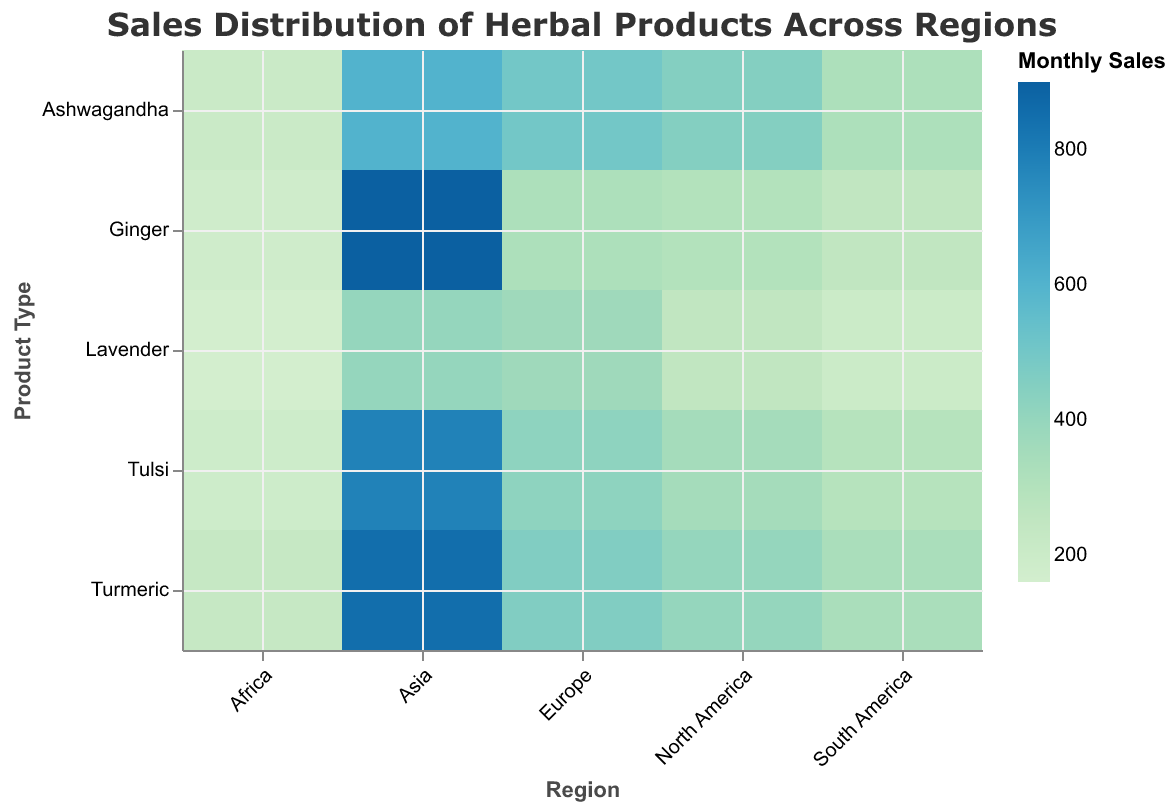Which region has the highest monthly sales for Ginger? Look for the correct cell in the heatmap by locating the intersection of the "Asia" row and "Ginger" column, which has the highest color intensity indicating the highest sales.
Answer: Asia What is the total monthly sales of Lavender across all regions? Sum the values for Lavender across all regions: 250 (North America) + 370 (Europe) + 400 (Asia) + 200 (South America) + 160 (Africa). The total is 1380.
Answer: 1380 How do the sales of Ashwagandha in North America compare to Europe? Compare the shade of the cell intersecting "North America" and "Ashwagandha" (450 units) with the cell intersecting "Europe" and "Ashwagandha" (500 units). Ashwagandha sales are higher in Europe.
Answer: Europe Which product recorded the lowest monthly sales in Africa? Identify the lightest-colored cell in the "Africa" row, which corresponds to Lavender with 160 units.
Answer: Lavender Which region has the most evenly distributed sales across all product types? Analyze the regions for cells with similar color intensities across all product types; "North America" and "South America" show relatively consistent intensities, but exact equal distribution would be best judged numerically.
Answer: South America Is there a notable difference in the sales pattern of Tulsi between Asia and Africa? Comparing the cells for "Tulsi" in "Asia" (780) and "Africa" (190), Asia has a significantly higher intensity indicating much higher sales than Africa.
Answer: Yes What's the difference in monthly sales of Turmeric between Asia and North America? Subtract the Turmeric sales in Asia (850 units) by the sales in North America (400 units), resulting in a difference of 450 units.
Answer: 450 Which two regions have the largest disparity in sales for Turmeric? Compare the highest and lowest cells in the "Turmeric" column. Asia (850 units) and Africa (230 units) show the largest disparity.
Answer: Asia and Africa What is the average monthly sales of Ginger across all regions? Calculate the sum of Ginger sales across all regions: 300 (North America) + 320 (Europe) + 900 (Asia) + 250 (South America) + 180 (Africa). The sum is 1950. Divide this by the number of regions (5) to get 1950 / 5, which equals 390.
Answer: 390 